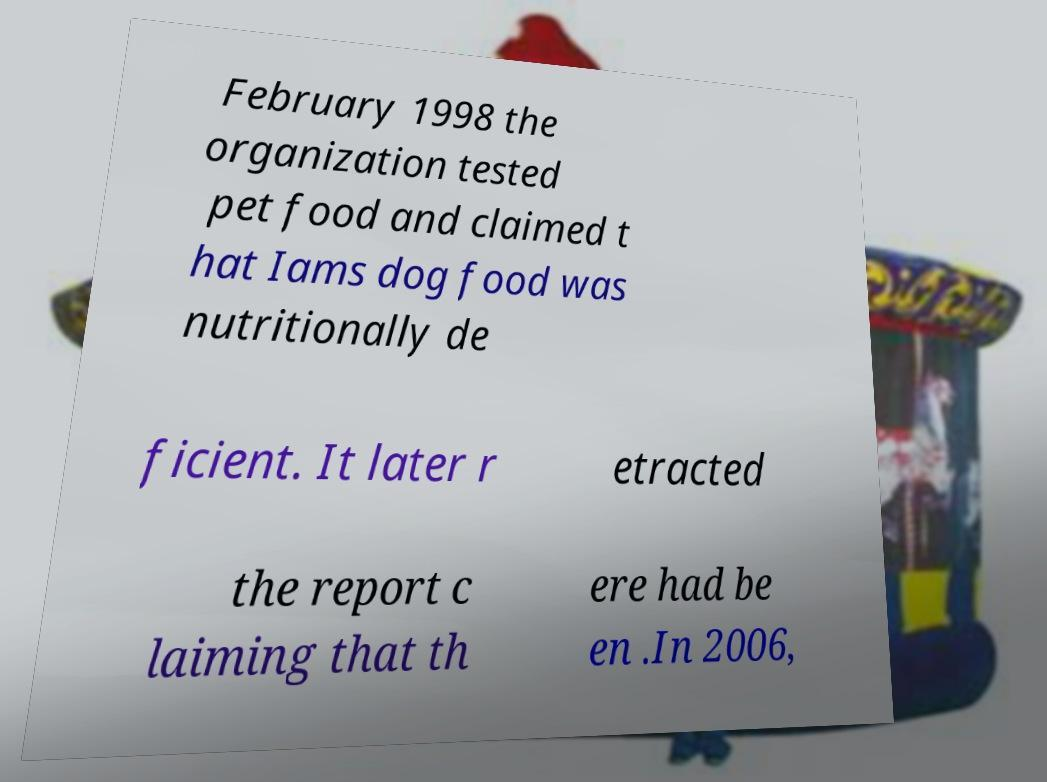Could you extract and type out the text from this image? February 1998 the organization tested pet food and claimed t hat Iams dog food was nutritionally de ficient. It later r etracted the report c laiming that th ere had be en .In 2006, 